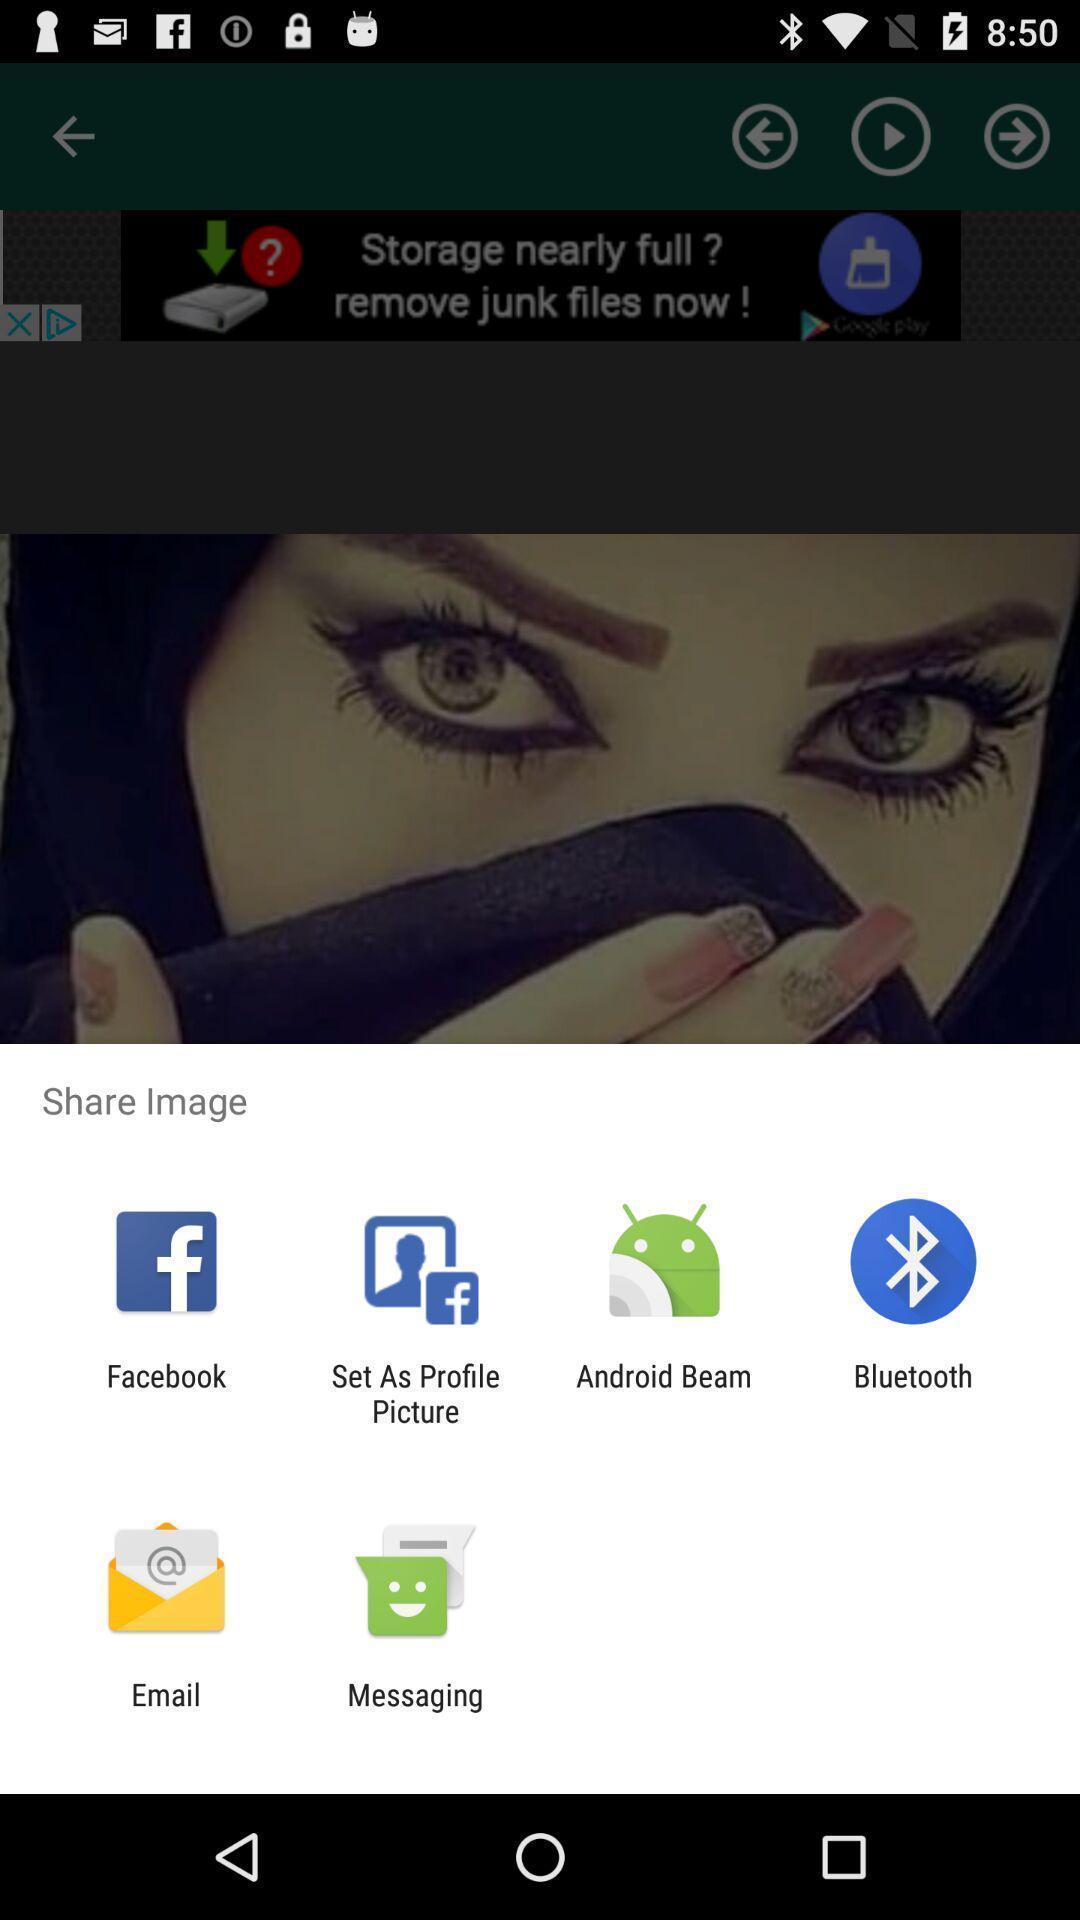Tell me what you see in this picture. Pop-up shows share option with multiple applications. 